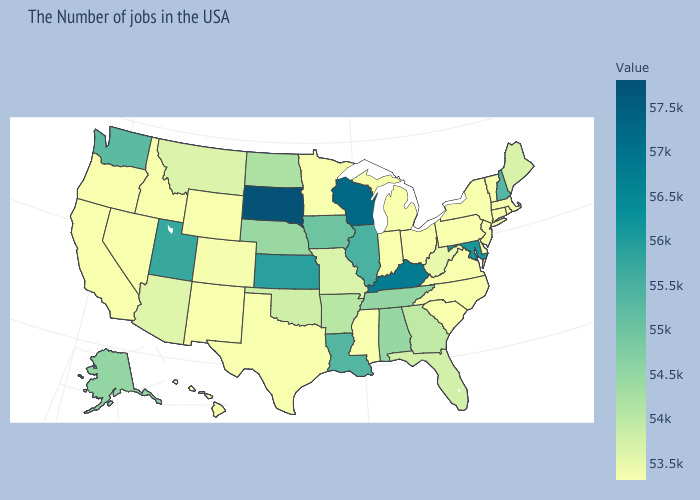Does Vermont have the lowest value in the USA?
Write a very short answer. Yes. Which states have the lowest value in the West?
Quick response, please. Wyoming, New Mexico, Idaho, Nevada, California, Oregon, Hawaii. Among the states that border Mississippi , does Louisiana have the highest value?
Be succinct. Yes. Does the map have missing data?
Be succinct. No. Which states have the lowest value in the MidWest?
Write a very short answer. Ohio, Michigan, Indiana, Minnesota. Does South Dakota have the highest value in the USA?
Write a very short answer. Yes. Does the map have missing data?
Keep it brief. No. 